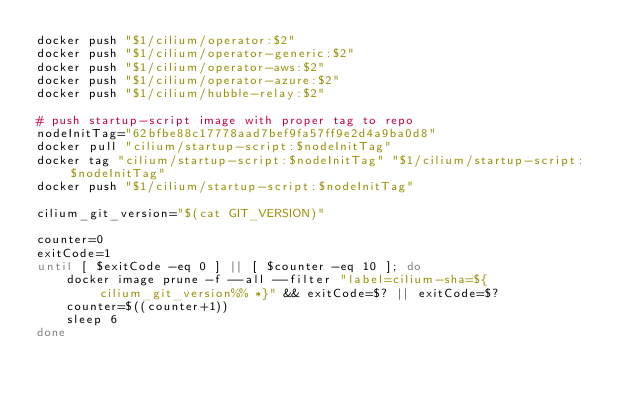Convert code to text. <code><loc_0><loc_0><loc_500><loc_500><_Bash_>docker push "$1/cilium/operator:$2"
docker push "$1/cilium/operator-generic:$2"
docker push "$1/cilium/operator-aws:$2"
docker push "$1/cilium/operator-azure:$2"
docker push "$1/cilium/hubble-relay:$2"

# push startup-script image with proper tag to repo
nodeInitTag="62bfbe88c17778aad7bef9fa57ff9e2d4a9ba0d8"
docker pull "cilium/startup-script:$nodeInitTag"
docker tag "cilium/startup-script:$nodeInitTag" "$1/cilium/startup-script:$nodeInitTag"
docker push "$1/cilium/startup-script:$nodeInitTag"

cilium_git_version="$(cat GIT_VERSION)"

counter=0
exitCode=1
until [ $exitCode -eq 0 ] || [ $counter -eq 10 ]; do
	docker image prune -f --all --filter "label=cilium-sha=${cilium_git_version%% *}" && exitCode=$? || exitCode=$?
	counter=$((counter+1))
	sleep 6
done
</code> 